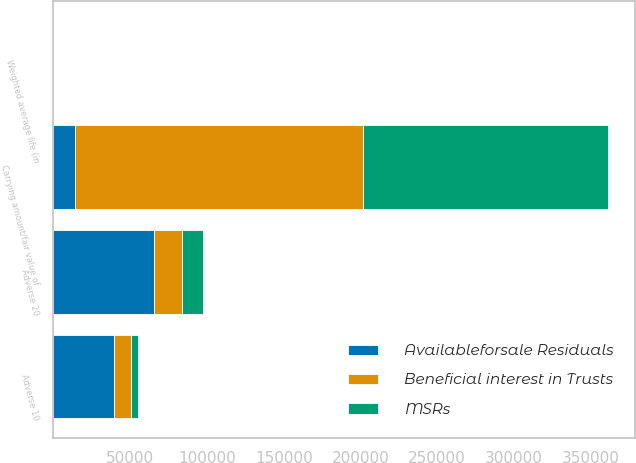Convert chart to OTSL. <chart><loc_0><loc_0><loc_500><loc_500><stacked_bar_chart><ecel><fcel>Carrying amount/fair value of<fcel>Weighted average life (in<fcel>Adverse 10<fcel>Adverse 20<nl><fcel>MSRs<fcel>159058<fcel>1.9<fcel>4330<fcel>13924<nl><fcel>Beneficial interest in Trusts<fcel>188014<fcel>1.9<fcel>11656<fcel>17892<nl><fcel>Availableforsale Residuals<fcel>13924<fcel>1.3<fcel>39163<fcel>65779<nl></chart> 